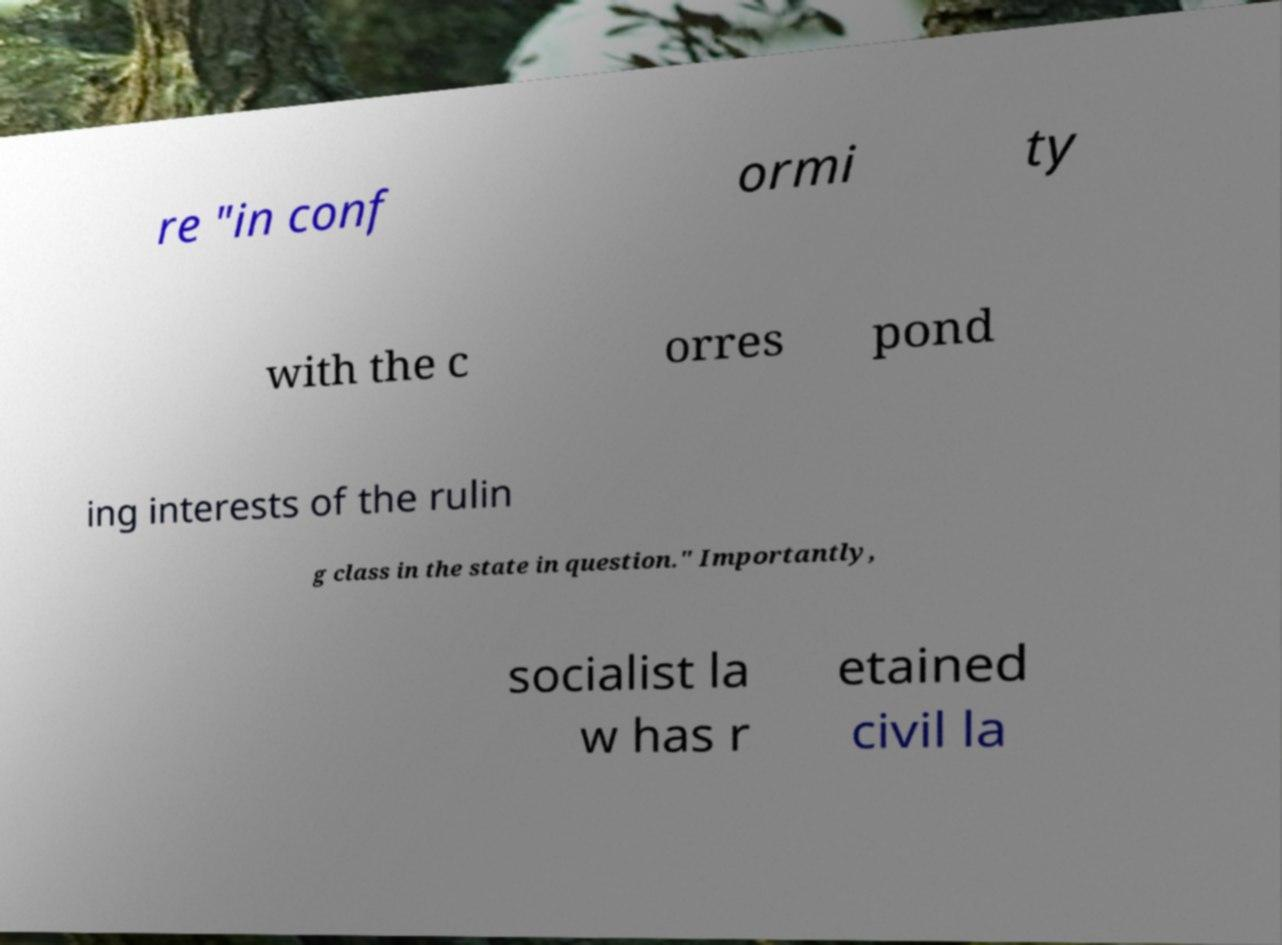There's text embedded in this image that I need extracted. Can you transcribe it verbatim? re "in conf ormi ty with the c orres pond ing interests of the rulin g class in the state in question." Importantly, socialist la w has r etained civil la 